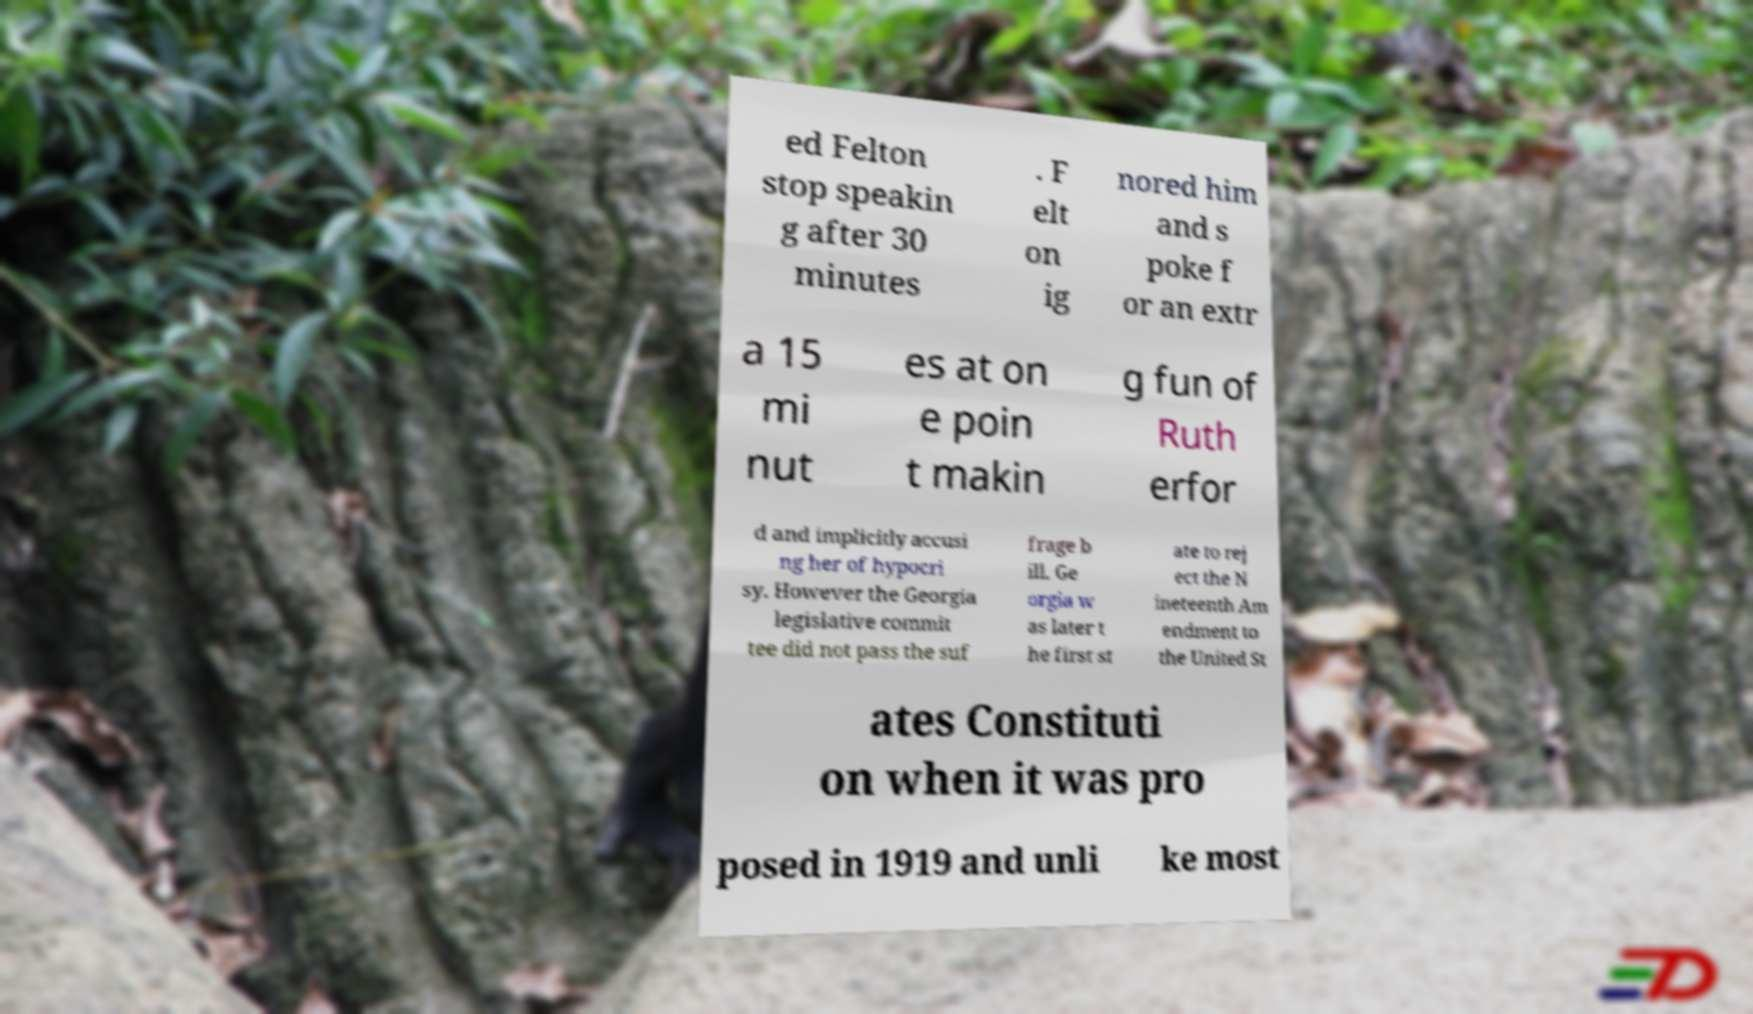Could you extract and type out the text from this image? ed Felton stop speakin g after 30 minutes . F elt on ig nored him and s poke f or an extr a 15 mi nut es at on e poin t makin g fun of Ruth erfor d and implicitly accusi ng her of hypocri sy. However the Georgia legislative commit tee did not pass the suf frage b ill. Ge orgia w as later t he first st ate to rej ect the N ineteenth Am endment to the United St ates Constituti on when it was pro posed in 1919 and unli ke most 